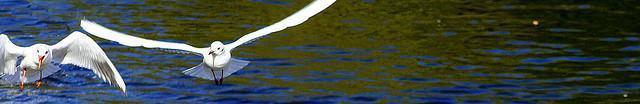How many birds are there?
Give a very brief answer. 2. 